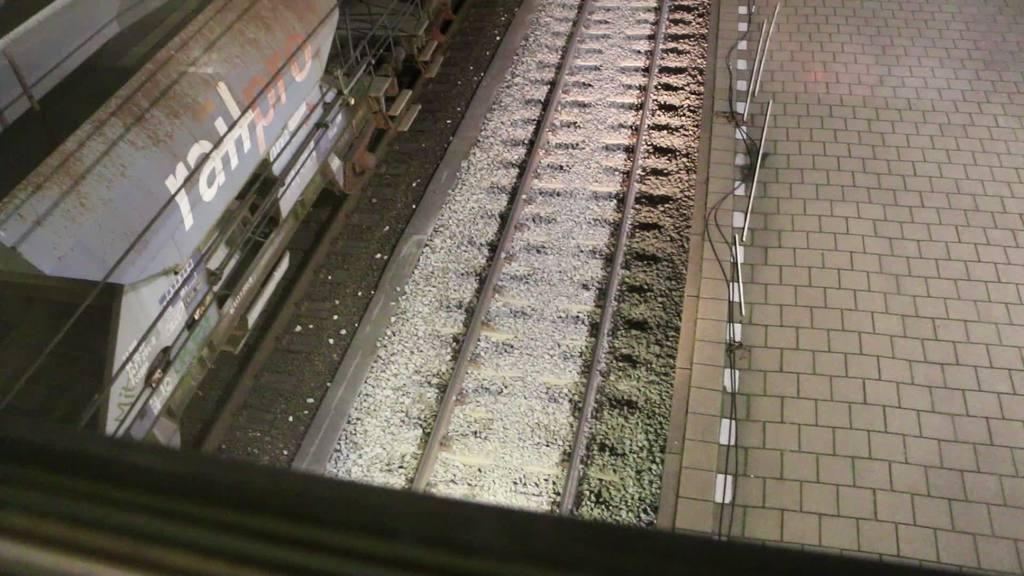Could you give a brief overview of what you see in this image? In the middle of the picture, we see the concrete stones and the railway tracks. On the left side, we see a train is moving on the railway tracks. On the right side, we see a pavement or the platform. This picture might be clicked in the railway station. 